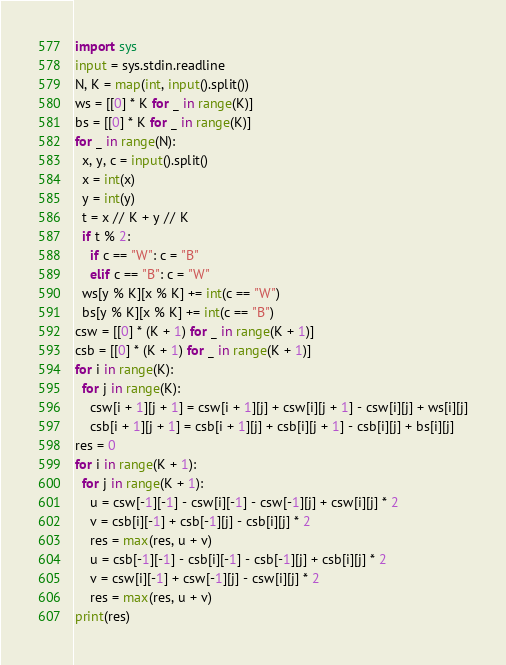<code> <loc_0><loc_0><loc_500><loc_500><_Python_>import sys
input = sys.stdin.readline
N, K = map(int, input().split())
ws = [[0] * K for _ in range(K)]
bs = [[0] * K for _ in range(K)]
for _ in range(N):
  x, y, c = input().split()
  x = int(x)
  y = int(y)
  t = x // K + y // K
  if t % 2:
    if c == "W": c = "B"
    elif c == "B": c = "W"
  ws[y % K][x % K] += int(c == "W")
  bs[y % K][x % K] += int(c == "B")
csw = [[0] * (K + 1) for _ in range(K + 1)]
csb = [[0] * (K + 1) for _ in range(K + 1)]
for i in range(K):
  for j in range(K):
    csw[i + 1][j + 1] = csw[i + 1][j] + csw[i][j + 1] - csw[i][j] + ws[i][j]
    csb[i + 1][j + 1] = csb[i + 1][j] + csb[i][j + 1] - csb[i][j] + bs[i][j]
res = 0
for i in range(K + 1):
  for j in range(K + 1):
    u = csw[-1][-1] - csw[i][-1] - csw[-1][j] + csw[i][j] * 2
    v = csb[i][-1] + csb[-1][j] - csb[i][j] * 2
    res = max(res, u + v)
    u = csb[-1][-1] - csb[i][-1] - csb[-1][j] + csb[i][j] * 2
    v = csw[i][-1] + csw[-1][j] - csw[i][j] * 2
    res = max(res, u + v)
print(res)</code> 